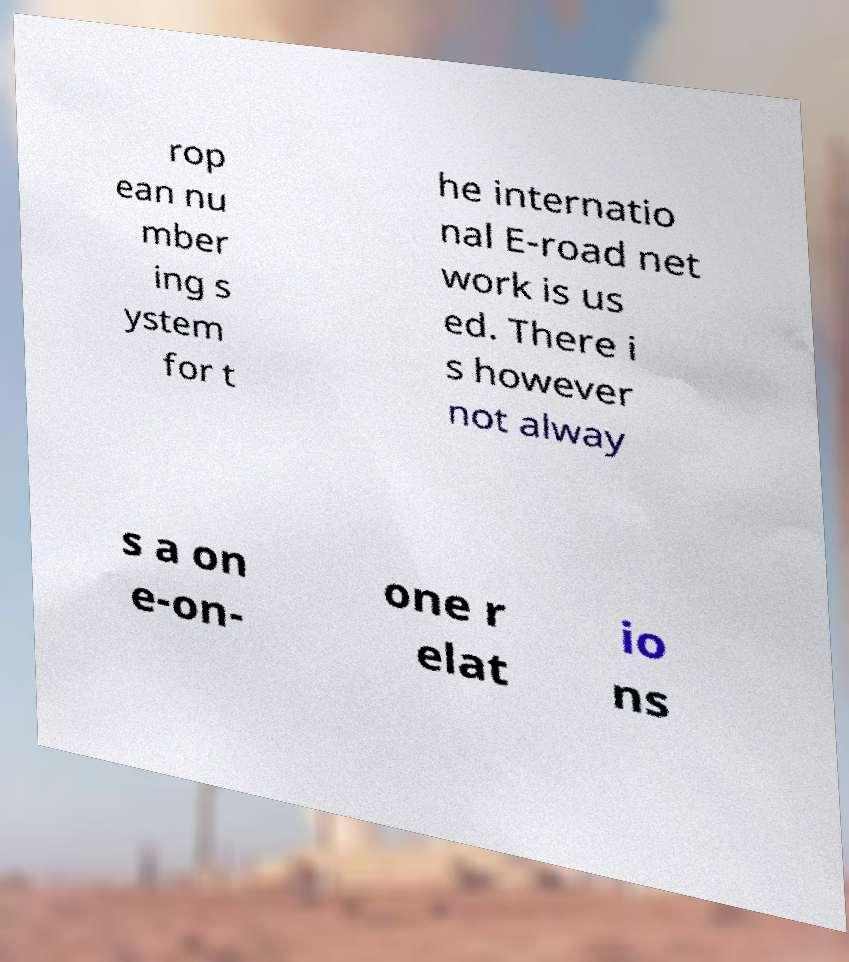What messages or text are displayed in this image? I need them in a readable, typed format. rop ean nu mber ing s ystem for t he internatio nal E-road net work is us ed. There i s however not alway s a on e-on- one r elat io ns 